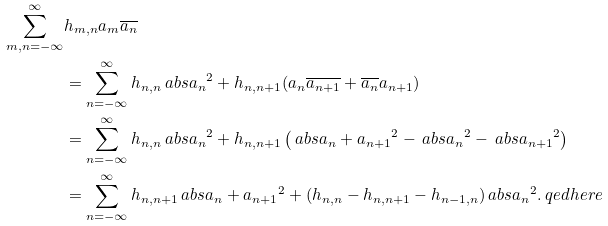Convert formula to latex. <formula><loc_0><loc_0><loc_500><loc_500>\sum _ { m , n = - \infty } ^ { \infty } & h _ { m , n } a _ { m } \overline { a _ { n } } \\ & = \sum _ { n = - \infty } ^ { \infty } h _ { n , n } \ a b s { a _ { n } } ^ { 2 } + h _ { n , n + 1 } ( a _ { n } \overline { a _ { n + 1 } } + \overline { a _ { n } } a _ { n + 1 } ) \\ & = \sum _ { n = - \infty } ^ { \infty } h _ { n , n } \ a b s { a _ { n } } ^ { 2 } + h _ { n , n + 1 } \left ( \ a b s { a _ { n } + a _ { n + 1 } } ^ { 2 } - \ a b s { a _ { n } } ^ { 2 } - \ a b s { a _ { n + 1 } } ^ { 2 } \right ) \\ & = \sum _ { n = - \infty } ^ { \infty } h _ { n , n + 1 } \ a b s { a _ { n } + a _ { n + 1 } } ^ { 2 } + ( h _ { n , n } - h _ { n , n + 1 } - h _ { n - 1 , n } ) \ a b s { a _ { n } } ^ { 2 } . \ q e d h e r e</formula> 